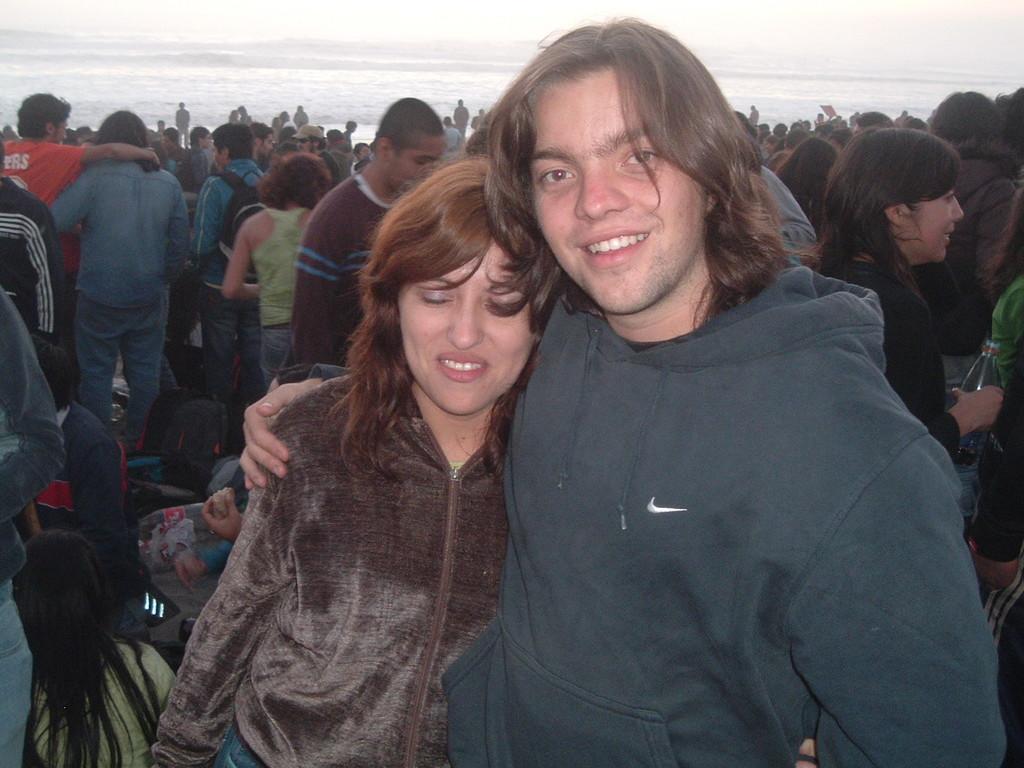In one or two sentences, can you explain what this image depicts? In this picture I can see a man and a woman, there are group of people, and in the background there is water. 